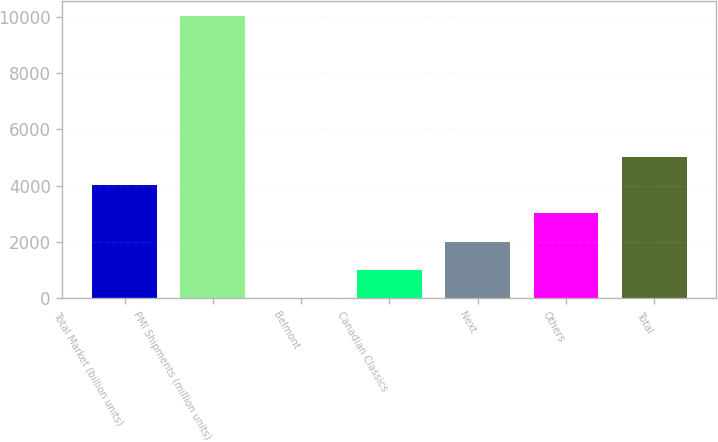<chart> <loc_0><loc_0><loc_500><loc_500><bar_chart><fcel>Total Market (billion units)<fcel>PMI Shipments (million units)<fcel>Belmont<fcel>Canadian Classics<fcel>Next<fcel>Others<fcel>Total<nl><fcel>4021.82<fcel>10049<fcel>3.7<fcel>1008.23<fcel>2012.76<fcel>3017.29<fcel>5026.35<nl></chart> 